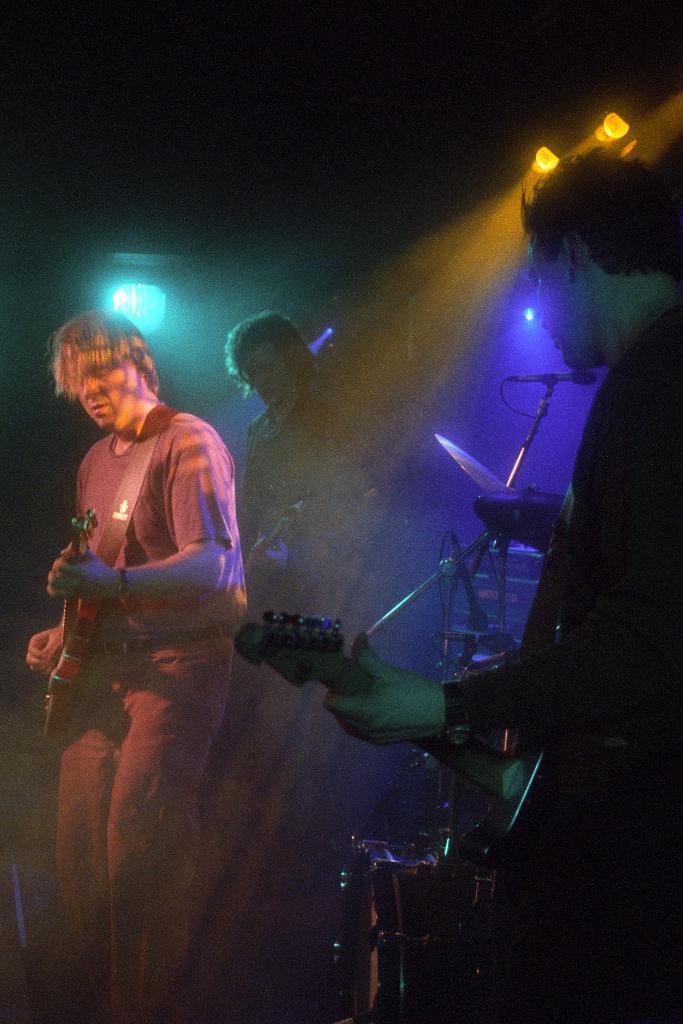In one or two sentences, can you explain what this image depicts? In the image we can see there are people who are holding guitar in their hand. 